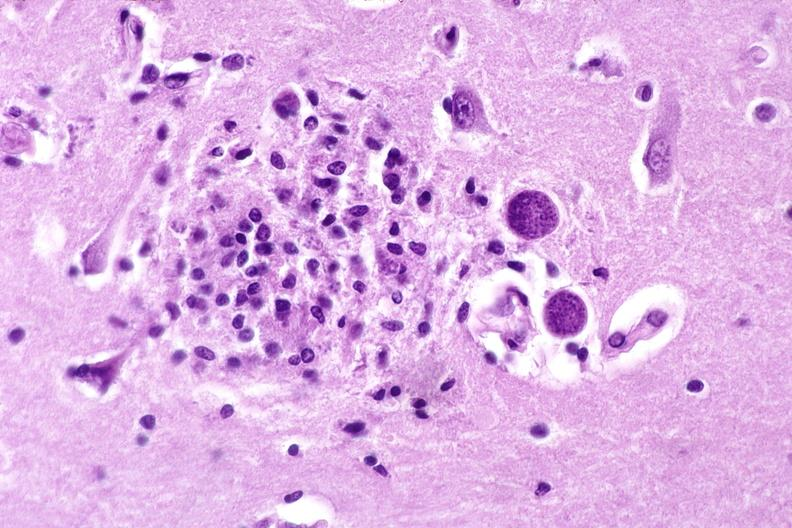s this fixed tissue present?
Answer the question using a single word or phrase. No 